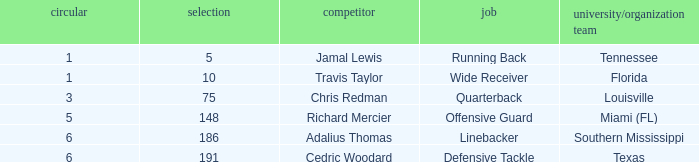Would you be able to parse every entry in this table? {'header': ['circular', 'selection', 'competitor', 'job', 'university/organization team'], 'rows': [['1', '5', 'Jamal Lewis', 'Running Back', 'Tennessee'], ['1', '10', 'Travis Taylor', 'Wide Receiver', 'Florida'], ['3', '75', 'Chris Redman', 'Quarterback', 'Louisville'], ['5', '148', 'Richard Mercier', 'Offensive Guard', 'Miami (FL)'], ['6', '186', 'Adalius Thomas', 'Linebacker', 'Southern Mississippi'], ['6', '191', 'Cedric Woodard', 'Defensive Tackle', 'Texas']]} What's the highest round that louisville drafted into when their pick was over 75? None. 